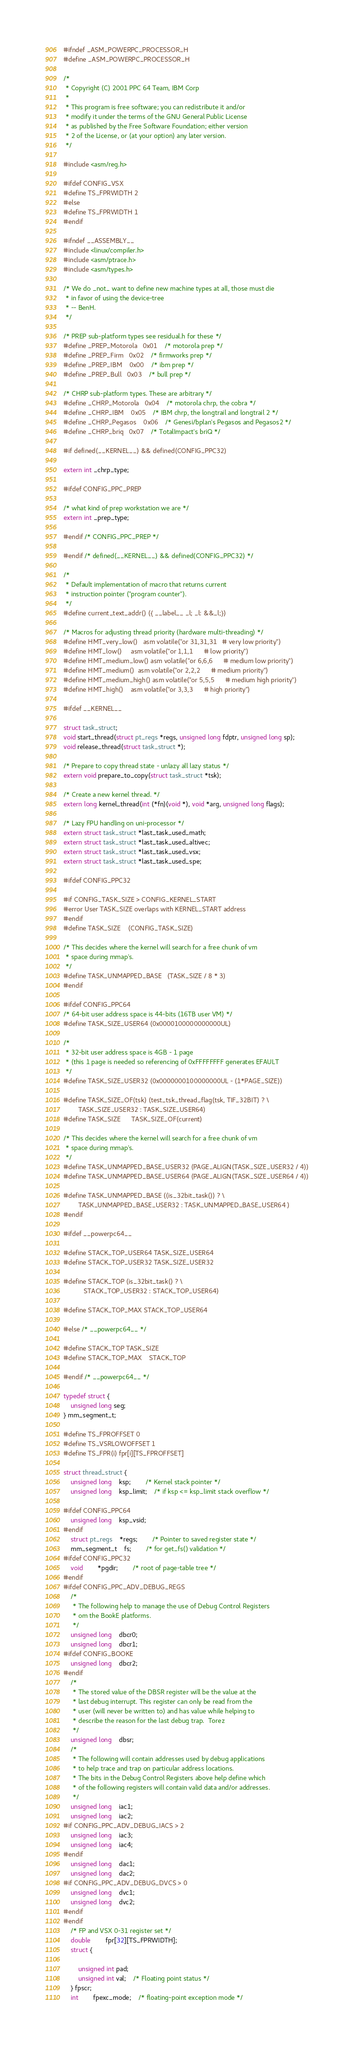<code> <loc_0><loc_0><loc_500><loc_500><_C_>#ifndef _ASM_POWERPC_PROCESSOR_H
#define _ASM_POWERPC_PROCESSOR_H

/*
 * Copyright (C) 2001 PPC 64 Team, IBM Corp
 *
 * This program is free software; you can redistribute it and/or
 * modify it under the terms of the GNU General Public License
 * as published by the Free Software Foundation; either version
 * 2 of the License, or (at your option) any later version.
 */

#include <asm/reg.h>

#ifdef CONFIG_VSX
#define TS_FPRWIDTH 2
#else
#define TS_FPRWIDTH 1
#endif

#ifndef __ASSEMBLY__
#include <linux/compiler.h>
#include <asm/ptrace.h>
#include <asm/types.h>

/* We do _not_ want to define new machine types at all, those must die
 * in favor of using the device-tree
 * -- BenH.
 */

/* PREP sub-platform types see residual.h for these */
#define _PREP_Motorola	0x01	/* motorola prep */
#define _PREP_Firm	0x02	/* firmworks prep */
#define _PREP_IBM	0x00	/* ibm prep */
#define _PREP_Bull	0x03	/* bull prep */

/* CHRP sub-platform types. These are arbitrary */
#define _CHRP_Motorola	0x04	/* motorola chrp, the cobra */
#define _CHRP_IBM	0x05	/* IBM chrp, the longtrail and longtrail 2 */
#define _CHRP_Pegasos	0x06	/* Genesi/bplan's Pegasos and Pegasos2 */
#define _CHRP_briq	0x07	/* TotalImpact's briQ */

#if defined(__KERNEL__) && defined(CONFIG_PPC32)

extern int _chrp_type;

#ifdef CONFIG_PPC_PREP

/* what kind of prep workstation we are */
extern int _prep_type;

#endif /* CONFIG_PPC_PREP */

#endif /* defined(__KERNEL__) && defined(CONFIG_PPC32) */

/*
 * Default implementation of macro that returns current
 * instruction pointer ("program counter").
 */
#define current_text_addr() ({ __label__ _l; _l: &&_l;})

/* Macros for adjusting thread priority (hardware multi-threading) */
#define HMT_very_low()   asm volatile("or 31,31,31   # very low priority")
#define HMT_low()	 asm volatile("or 1,1,1	     # low priority")
#define HMT_medium_low() asm volatile("or 6,6,6      # medium low priority")
#define HMT_medium()	 asm volatile("or 2,2,2	     # medium priority")
#define HMT_medium_high() asm volatile("or 5,5,5      # medium high priority")
#define HMT_high()	 asm volatile("or 3,3,3	     # high priority")

#ifdef __KERNEL__

struct task_struct;
void start_thread(struct pt_regs *regs, unsigned long fdptr, unsigned long sp);
void release_thread(struct task_struct *);

/* Prepare to copy thread state - unlazy all lazy status */
extern void prepare_to_copy(struct task_struct *tsk);

/* Create a new kernel thread. */
extern long kernel_thread(int (*fn)(void *), void *arg, unsigned long flags);

/* Lazy FPU handling on uni-processor */
extern struct task_struct *last_task_used_math;
extern struct task_struct *last_task_used_altivec;
extern struct task_struct *last_task_used_vsx;
extern struct task_struct *last_task_used_spe;

#ifdef CONFIG_PPC32

#if CONFIG_TASK_SIZE > CONFIG_KERNEL_START
#error User TASK_SIZE overlaps with KERNEL_START address
#endif
#define TASK_SIZE	(CONFIG_TASK_SIZE)

/* This decides where the kernel will search for a free chunk of vm
 * space during mmap's.
 */
#define TASK_UNMAPPED_BASE	(TASK_SIZE / 8 * 3)
#endif

#ifdef CONFIG_PPC64
/* 64-bit user address space is 44-bits (16TB user VM) */
#define TASK_SIZE_USER64 (0x0000100000000000UL)

/* 
 * 32-bit user address space is 4GB - 1 page 
 * (this 1 page is needed so referencing of 0xFFFFFFFF generates EFAULT
 */
#define TASK_SIZE_USER32 (0x0000000100000000UL - (1*PAGE_SIZE))

#define TASK_SIZE_OF(tsk) (test_tsk_thread_flag(tsk, TIF_32BIT) ? \
		TASK_SIZE_USER32 : TASK_SIZE_USER64)
#define TASK_SIZE	  TASK_SIZE_OF(current)

/* This decides where the kernel will search for a free chunk of vm
 * space during mmap's.
 */
#define TASK_UNMAPPED_BASE_USER32 (PAGE_ALIGN(TASK_SIZE_USER32 / 4))
#define TASK_UNMAPPED_BASE_USER64 (PAGE_ALIGN(TASK_SIZE_USER64 / 4))

#define TASK_UNMAPPED_BASE ((is_32bit_task()) ? \
		TASK_UNMAPPED_BASE_USER32 : TASK_UNMAPPED_BASE_USER64 )
#endif

#ifdef __powerpc64__

#define STACK_TOP_USER64 TASK_SIZE_USER64
#define STACK_TOP_USER32 TASK_SIZE_USER32

#define STACK_TOP (is_32bit_task() ? \
		   STACK_TOP_USER32 : STACK_TOP_USER64)

#define STACK_TOP_MAX STACK_TOP_USER64

#else /* __powerpc64__ */

#define STACK_TOP TASK_SIZE
#define STACK_TOP_MAX	STACK_TOP

#endif /* __powerpc64__ */

typedef struct {
	unsigned long seg;
} mm_segment_t;

#define TS_FPROFFSET 0
#define TS_VSRLOWOFFSET 1
#define TS_FPR(i) fpr[i][TS_FPROFFSET]

struct thread_struct {
	unsigned long	ksp;		/* Kernel stack pointer */
	unsigned long	ksp_limit;	/* if ksp <= ksp_limit stack overflow */

#ifdef CONFIG_PPC64
	unsigned long	ksp_vsid;
#endif
	struct pt_regs	*regs;		/* Pointer to saved register state */
	mm_segment_t	fs;		/* for get_fs() validation */
#ifdef CONFIG_PPC32
	void		*pgdir;		/* root of page-table tree */
#endif
#ifdef CONFIG_PPC_ADV_DEBUG_REGS
	/*
	 * The following help to manage the use of Debug Control Registers
	 * om the BookE platforms.
	 */
	unsigned long	dbcr0;
	unsigned long	dbcr1;
#ifdef CONFIG_BOOKE
	unsigned long	dbcr2;
#endif
	/*
	 * The stored value of the DBSR register will be the value at the
	 * last debug interrupt. This register can only be read from the
	 * user (will never be written to) and has value while helping to
	 * describe the reason for the last debug trap.  Torez
	 */
	unsigned long	dbsr;
	/*
	 * The following will contain addresses used by debug applications
	 * to help trace and trap on particular address locations.
	 * The bits in the Debug Control Registers above help define which
	 * of the following registers will contain valid data and/or addresses.
	 */
	unsigned long	iac1;
	unsigned long	iac2;
#if CONFIG_PPC_ADV_DEBUG_IACS > 2
	unsigned long	iac3;
	unsigned long	iac4;
#endif
	unsigned long	dac1;
	unsigned long	dac2;
#if CONFIG_PPC_ADV_DEBUG_DVCS > 0
	unsigned long	dvc1;
	unsigned long	dvc2;
#endif
#endif
	/* FP and VSX 0-31 register set */
	double		fpr[32][TS_FPRWIDTH];
	struct {

		unsigned int pad;
		unsigned int val;	/* Floating point status */
	} fpscr;
	int		fpexc_mode;	/* floating-point exception mode */</code> 